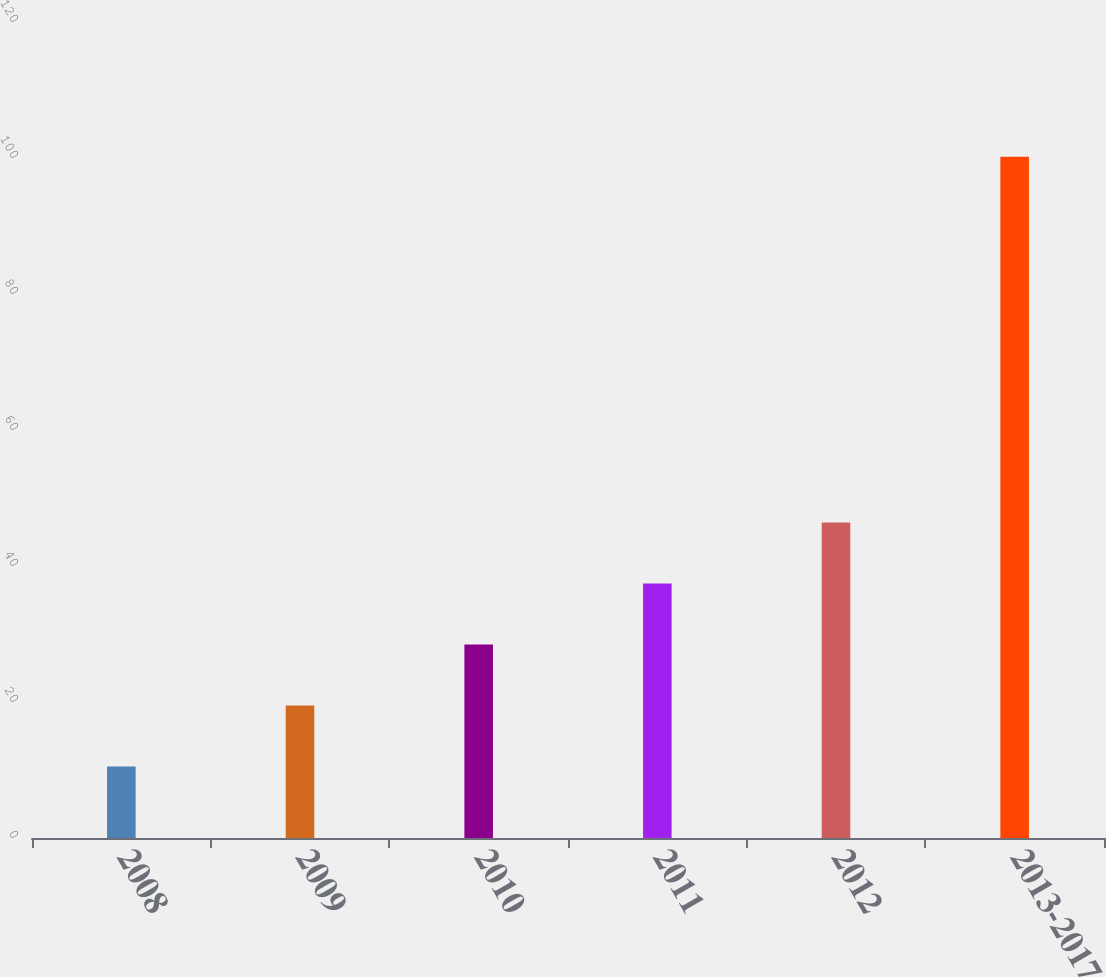Convert chart to OTSL. <chart><loc_0><loc_0><loc_500><loc_500><bar_chart><fcel>2008<fcel>2009<fcel>2010<fcel>2011<fcel>2012<fcel>2013-2017<nl><fcel>10.5<fcel>19.47<fcel>28.44<fcel>37.41<fcel>46.38<fcel>100.2<nl></chart> 